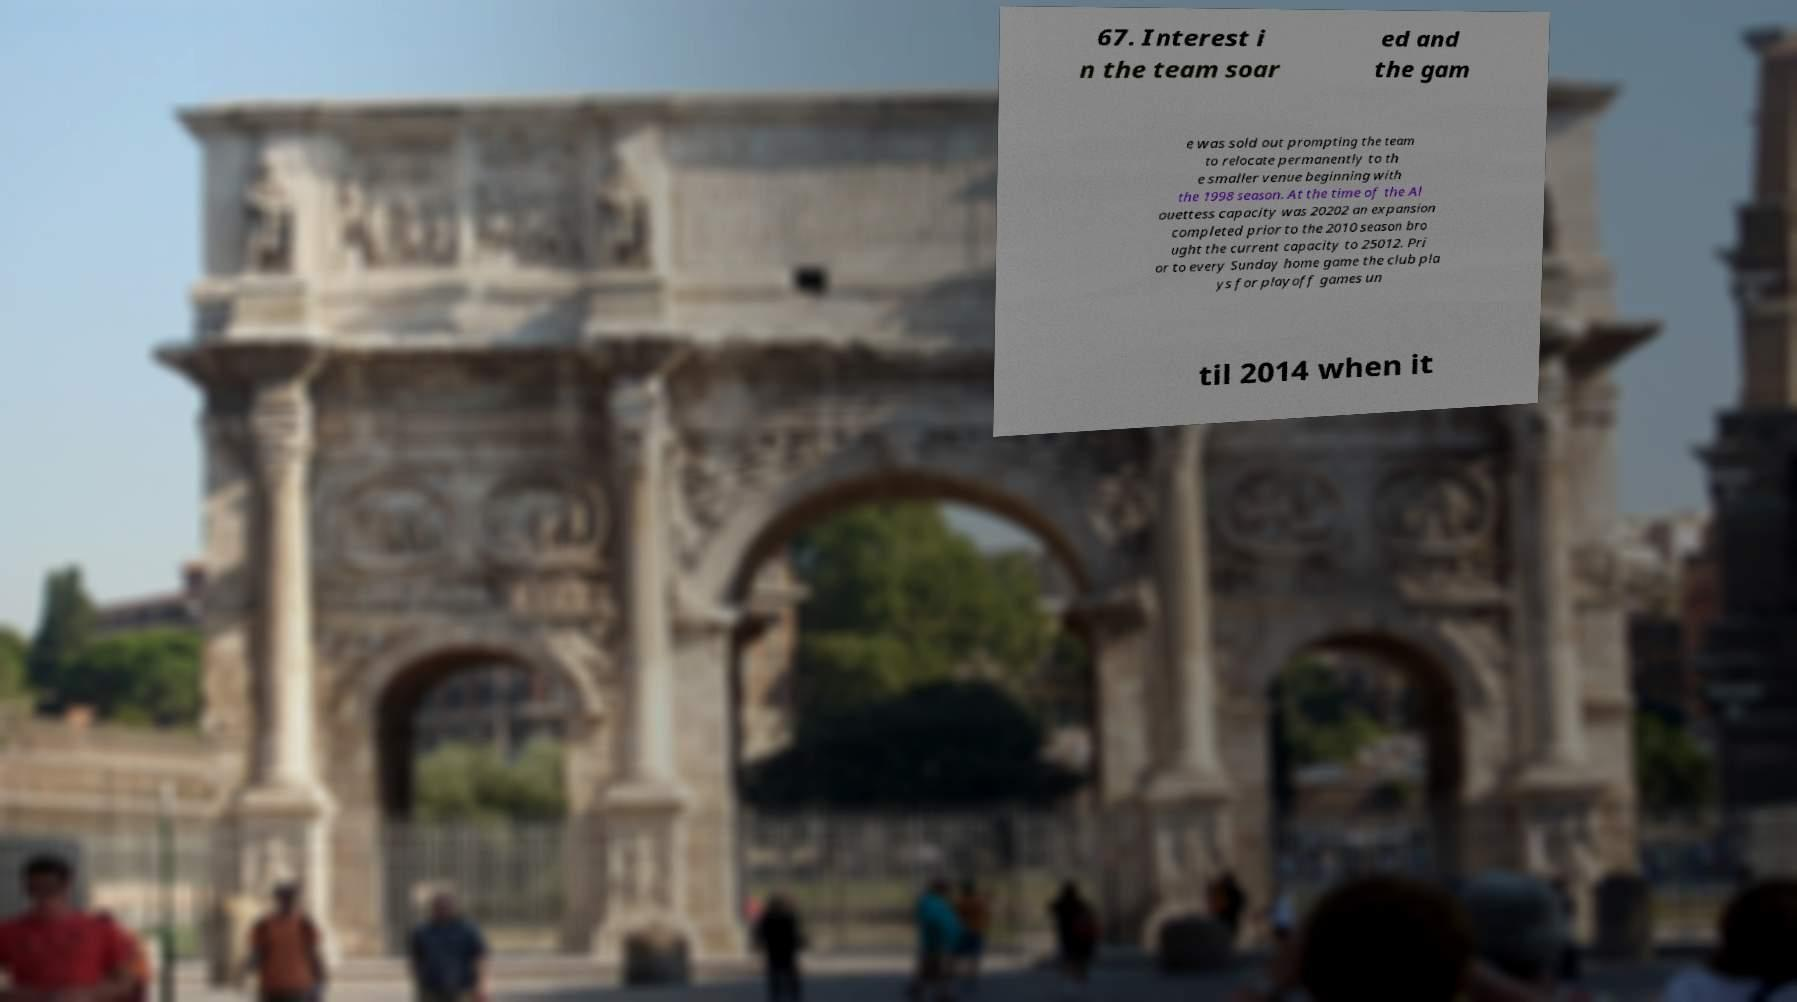Please identify and transcribe the text found in this image. 67. Interest i n the team soar ed and the gam e was sold out prompting the team to relocate permanently to th e smaller venue beginning with the 1998 season. At the time of the Al ouettess capacity was 20202 an expansion completed prior to the 2010 season bro ught the current capacity to 25012. Pri or to every Sunday home game the club pla ys for playoff games un til 2014 when it 